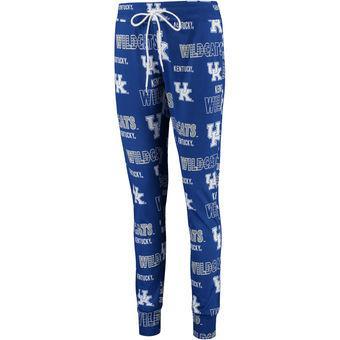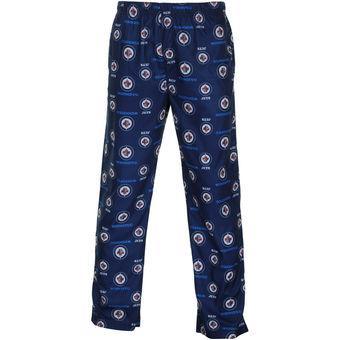The first image is the image on the left, the second image is the image on the right. Considering the images on both sides, is "at least one pair of pants is worn by a human." valid? Answer yes or no. No. 